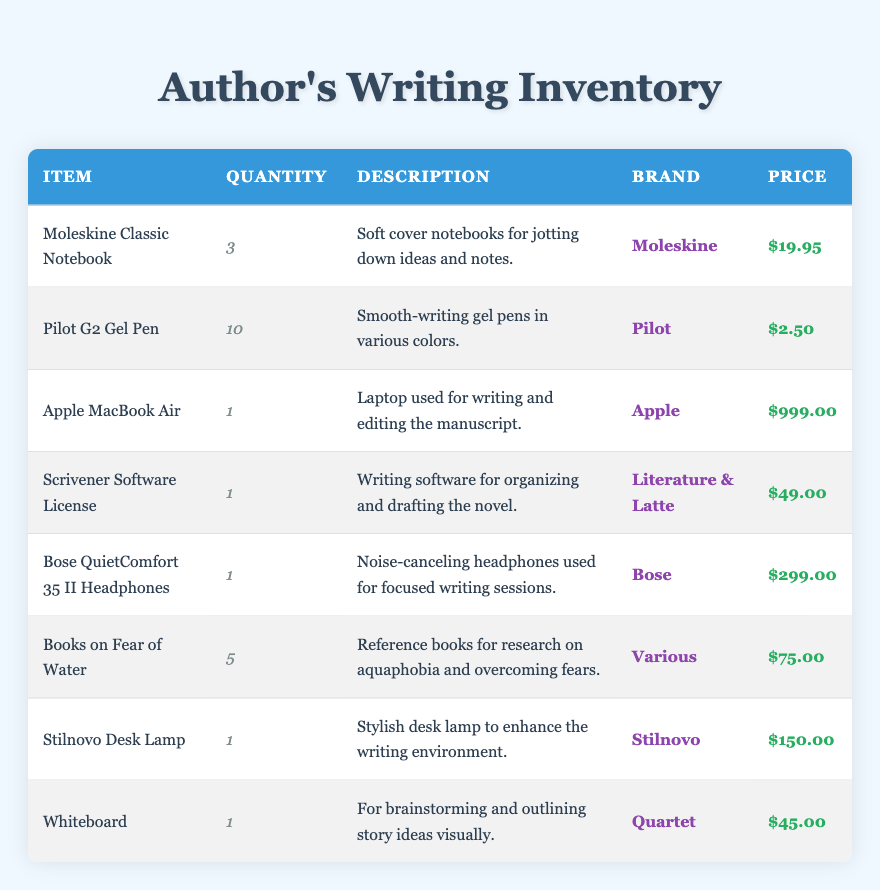What is the total quantity of Pilot G2 Gel Pens? The table lists the quantity of Pilot G2 Gel Pens as 10. Therefore, the total quantity is simply that value.
Answer: 10 How much do the Moleskine Classic Notebooks cost in total? Each Moleskine Classic Notebook costs $19.95, and there are 3 of them. The total cost is calculated as 3 x 19.95 = 59.85.
Answer: 59.85 Is there more than one Apple MacBook Air in the inventory? The table shows that there is only 1 Apple MacBook Air listed in the inventory. Therefore, the statement is false.
Answer: No What is the combined price of all writing materials (notebooks, pens, and desk lamp)? The total price of the Moleskine Classic Notebooks is 3 x 19.95 = 59.85, the Pilot G2 Gel Pens is 10 x 2.50 = 25.00, and the Stilnovo Desk Lamp is 150.00. Adding these gives 59.85 + 25.00 + 150.00 = 234.85.
Answer: 234.85 Are there any items that specifically address the theme of overcoming fear of water? Yes, the inventory includes "Books on Fear of Water," which are specifically for research on aquaphobia and overcoming fears.
Answer: Yes What is the average price of the items in the inventory? To find the average price, first sum the prices of all items: 19.95 + 2.50 + 999.00 + 49.00 + 299.00 + 75.00 + 150.00 + 45.00 = 1639.45. There are 8 items, so the average price is 1639.45 / 8 = 204.93.
Answer: 204.93 How many items in the inventory are priced over $100? Looking at the prices, the Apple MacBook Air, Bose QuietComfort 35 II Headphones, and Stilnovo Desk Lamp are all over $100, totaling 3 items.
Answer: 3 What is the total value of all the inventory? The total value is calculated by summing all item prices: 19.95 + 25.00 + 999.00 + 49.00 + 299.00 + 75.00 + 150.00 + 45.00 = 1639.95. Thus, the total inventory value is 1639.95.
Answer: 1639.95 